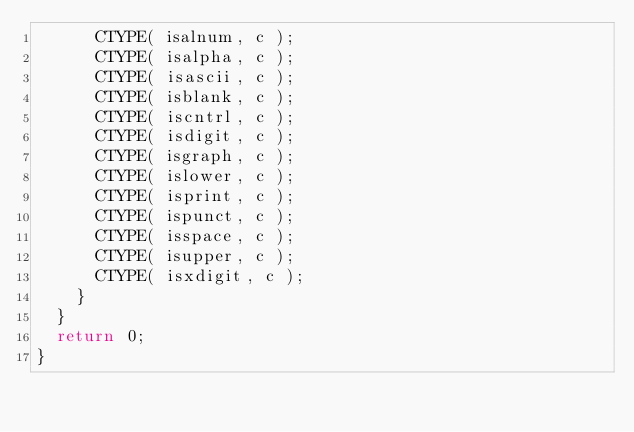<code> <loc_0><loc_0><loc_500><loc_500><_C_>      CTYPE( isalnum, c );
      CTYPE( isalpha, c );
      CTYPE( isascii, c );
      CTYPE( isblank, c );
      CTYPE( iscntrl, c );
      CTYPE( isdigit, c );
      CTYPE( isgraph, c );
      CTYPE( islower, c );
      CTYPE( isprint, c );
      CTYPE( ispunct, c );
      CTYPE( isspace, c );
      CTYPE( isupper, c );
      CTYPE( isxdigit, c );
    }
  }
  return 0;
}
</code> 